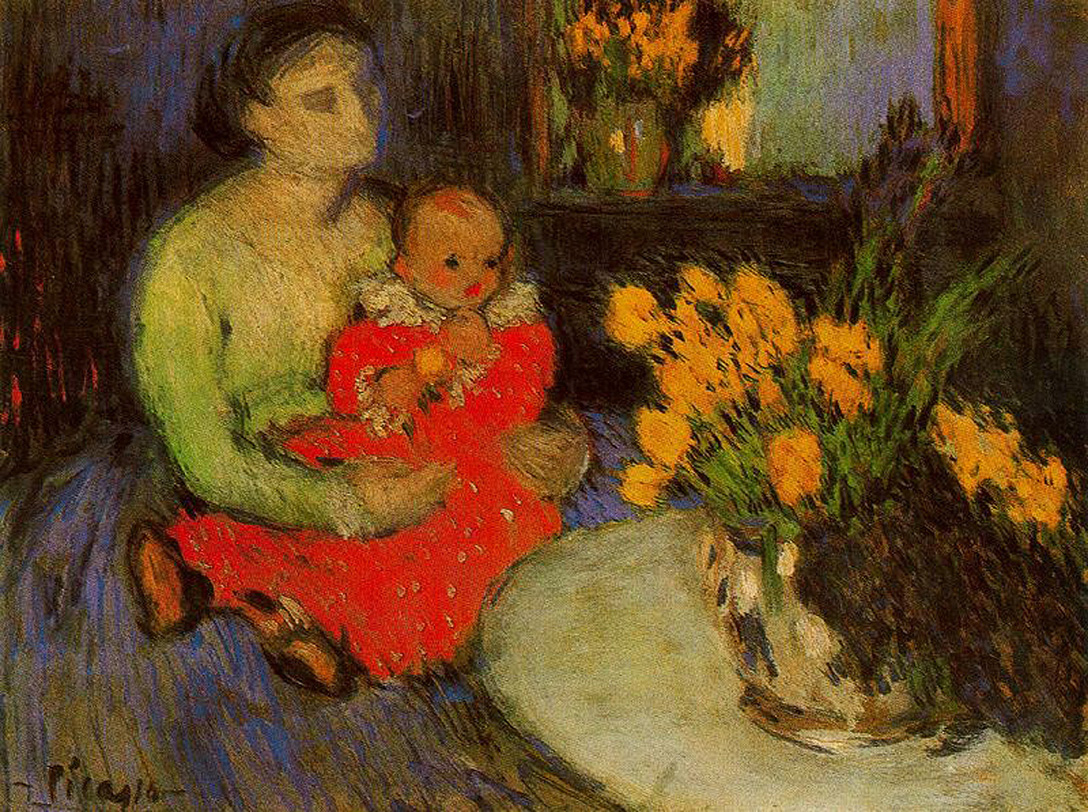Create a poem describing the painting. In a room dim and serene,
Lies a bond so pure, pristine.
A mother in her vibrant green,
Holds her child, a glowing scene.
Red dress bright against the night,
Flowers bloom in soft twilight.
Brushstrokes loose, colors sing,
A tale of love, a gentle spring. 